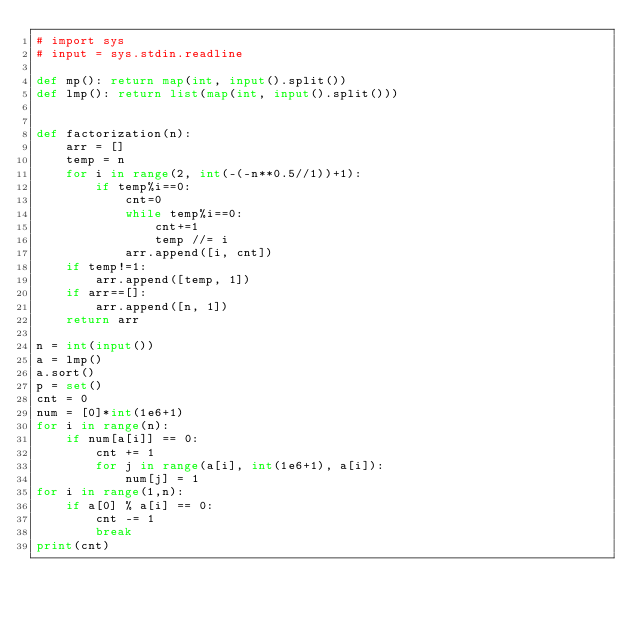Convert code to text. <code><loc_0><loc_0><loc_500><loc_500><_Python_># import sys
# input = sys.stdin.readline

def mp(): return map(int, input().split())
def lmp(): return list(map(int, input().split()))


def factorization(n):
    arr = []
    temp = n
    for i in range(2, int(-(-n**0.5//1))+1):
        if temp%i==0:
            cnt=0
            while temp%i==0:
                cnt+=1
                temp //= i
            arr.append([i, cnt])
    if temp!=1:
        arr.append([temp, 1])
    if arr==[]:
        arr.append([n, 1])
    return arr

n = int(input())
a = lmp()
a.sort()
p = set()
cnt = 0
num = [0]*int(1e6+1)
for i in range(n):
    if num[a[i]] == 0:
        cnt += 1
        for j in range(a[i], int(1e6+1), a[i]):
            num[j] = 1
for i in range(1,n):
    if a[0] % a[i] == 0:
        cnt -= 1
        break
print(cnt)




</code> 